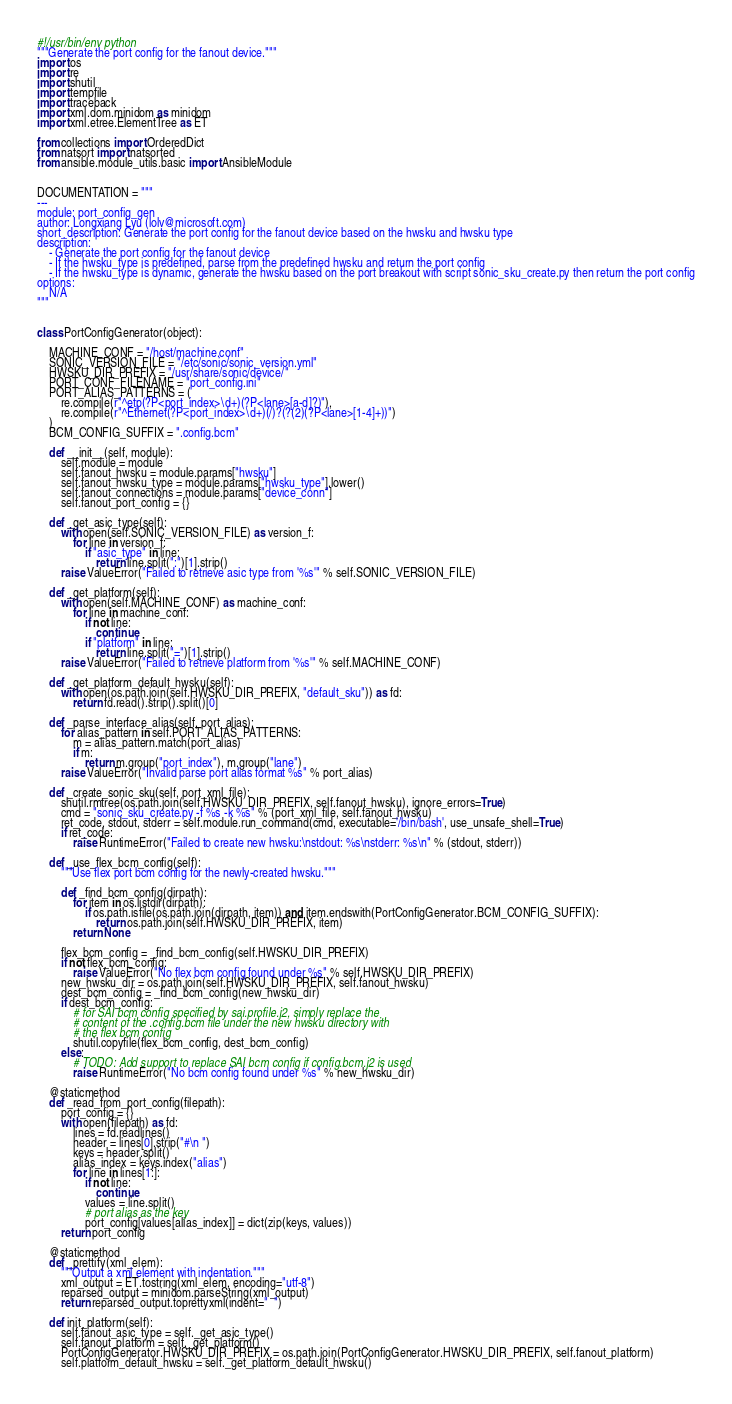Convert code to text. <code><loc_0><loc_0><loc_500><loc_500><_Python_>#!/usr/bin/env python
"""Generate the port config for the fanout device."""
import os
import re
import shutil
import tempfile
import traceback
import xml.dom.minidom as minidom
import xml.etree.ElementTree as ET

from collections import OrderedDict
from natsort import natsorted
from ansible.module_utils.basic import AnsibleModule


DOCUMENTATION = """
---
module: port_config_gen
author: Longxiang Lyu (lolv@microsoft.com)
short_description: Generate the port config for the fanout device based on the hwsku and hwsku type
description:
    - Generate the port config for the fanout device
    - If the hwsku_type is predefined, parse from the predefined hwsku and return the port config
    - If the hwsku_type is dynamic, generate the hwsku based on the port breakout with script sonic_sku_create.py then return the port config
options:
    N/A
"""


class PortConfigGenerator(object):

    MACHINE_CONF = "/host/machine.conf"
    SONIC_VERSION_FILE = "/etc/sonic/sonic_version.yml"
    HWSKU_DIR_PREFIX = "/usr/share/sonic/device/"
    PORT_CONF_FILENAME = "port_config.ini"
    PORT_ALIAS_PATTERNS = (
        re.compile(r"^etp(?P<port_index>\d+)(?P<lane>[a-d]?)"),
        re.compile(r"^Ethernet(?P<port_index>\d+)(/)?(?(2)(?P<lane>[1-4]+))")
    )
    BCM_CONFIG_SUFFIX = ".config.bcm"

    def __init__(self, module):
        self.module = module
        self.fanout_hwsku = module.params["hwsku"]
        self.fanout_hwsku_type = module.params["hwsku_type"].lower()
        self.fanout_connections = module.params["device_conn"]
        self.fanout_port_config = {}

    def _get_asic_type(self):
        with open(self.SONIC_VERSION_FILE) as version_f:
            for line in version_f:
                if "asic_type" in line:
                    return line.split(":")[1].strip()
        raise ValueError("Failed to retrieve asic type from '%s'" % self.SONIC_VERSION_FILE)

    def _get_platform(self):
        with open(self.MACHINE_CONF) as machine_conf:
            for line in machine_conf:
                if not line:
                    continue
                if "platform" in line:
                    return line.split("=")[1].strip()
        raise ValueError("Failed to retrieve platform from '%s'" % self.MACHINE_CONF)

    def _get_platform_default_hwsku(self):
        with open(os.path.join(self.HWSKU_DIR_PREFIX, "default_sku")) as fd:
            return fd.read().strip().split()[0]

    def _parse_interface_alias(self, port_alias):
        for alias_pattern in self.PORT_ALIAS_PATTERNS:
            m = alias_pattern.match(port_alias)
            if m:
                return m.group("port_index"), m.group("lane")
        raise ValueError("Invalid parse port alias format %s" % port_alias)

    def _create_sonic_sku(self, port_xml_file):
        shutil.rmtree(os.path.join(self.HWSKU_DIR_PREFIX, self.fanout_hwsku), ignore_errors=True)
        cmd = "sonic_sku_create.py -f %s -k %s" % (port_xml_file, self.fanout_hwsku)
        ret_code, stdout, stderr = self.module.run_command(cmd, executable='/bin/bash', use_unsafe_shell=True)
        if ret_code:
            raise RuntimeError("Failed to create new hwsku:\nstdout: %s\nstderr: %s\n" % (stdout, stderr))

    def _use_flex_bcm_config(self):
        """Use flex port bcm config for the newly-created hwsku."""

        def _find_bcm_config(dirpath):
            for item in os.listdir(dirpath):
                if os.path.isfile(os.path.join(dirpath, item)) and item.endswith(PortConfigGenerator.BCM_CONFIG_SUFFIX):
                    return os.path.join(self.HWSKU_DIR_PREFIX, item)
            return None

        flex_bcm_config = _find_bcm_config(self.HWSKU_DIR_PREFIX)
        if not flex_bcm_config:
            raise ValueError("No flex bcm config found under %s" % self.HWSKU_DIR_PREFIX)
        new_hwsku_dir = os.path.join(self.HWSKU_DIR_PREFIX, self.fanout_hwsku)
        dest_bcm_config = _find_bcm_config(new_hwsku_dir)
        if dest_bcm_config:
            # for SAI bcm config specified by sai.profile.j2, simply replace the
            # content of the .config.bcm file under the new hwsku directory with
            # the flex bcm config
            shutil.copyfile(flex_bcm_config, dest_bcm_config)
        else:
            # TODO: Add support to replace SAI bcm config if config.bcm.j2 is used
            raise RuntimeError("No bcm config found under %s" % new_hwsku_dir)

    @staticmethod
    def _read_from_port_config(filepath):
        port_config = {}
        with open(filepath) as fd:
            lines = fd.readlines()
            header = lines[0].strip("#\n ")
            keys = header.split()
            alias_index = keys.index("alias")
            for line in lines[1:]:
                if not line:
                    continue
                values = line.split()
                # port alias as the key
                port_config[values[alias_index]] = dict(zip(keys, values))
        return port_config

    @staticmethod
    def _prettify(xml_elem):
        """Output a xml element with indentation."""
        xml_output = ET.tostring(xml_elem, encoding="utf-8")
        reparsed_output = minidom.parseString(xml_output)
        return reparsed_output.toprettyxml(indent="  ")

    def init_platform(self):
        self.fanout_asic_type = self._get_asic_type()
        self.fanout_platform = self._get_platform()
        PortConfigGenerator.HWSKU_DIR_PREFIX = os.path.join(PortConfigGenerator.HWSKU_DIR_PREFIX, self.fanout_platform)
        self.platform_default_hwsku = self._get_platform_default_hwsku()</code> 